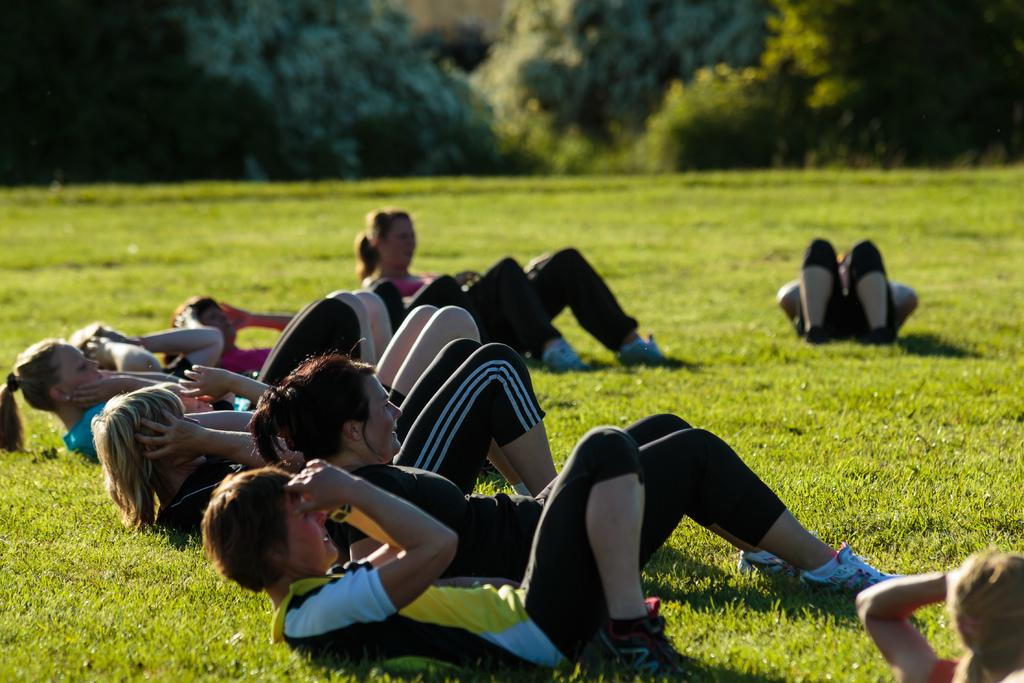Where is the image taken? The image is taken on the ground. What are the people in the image doing? The people are performing exercises. What can be seen in the background of the image? There are trees visible at the top of the image. What type of digestion can be observed in the image? There is no digestion present in the image; it features people performing exercises on the ground. What hope does the image convey? The image does not convey any specific hope or message; it simply shows people exercising on the ground. 